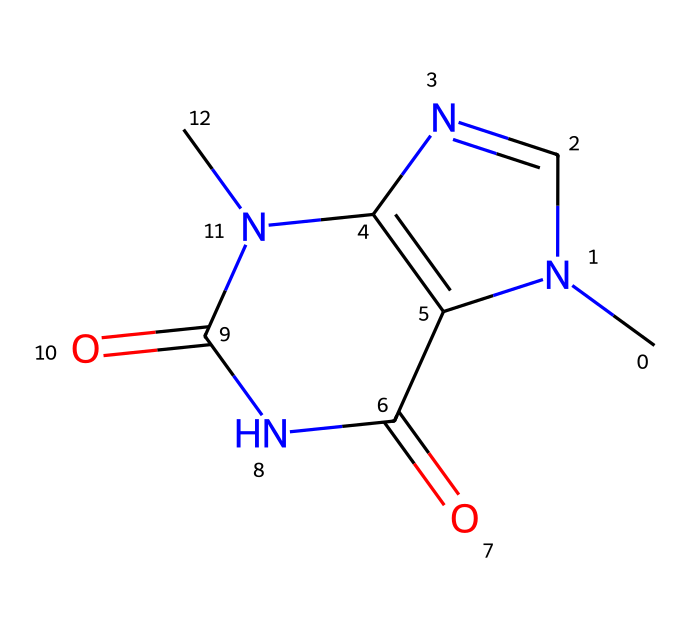what is the chemical name of this compound? The SMILES indicates the compound has a specific arrangement of atoms and functional groups typical of theobromine, which is a methylxanthine alkaloid found in chocolate.
Answer: theobromine how many nitrogen atoms are present in the structure? Analyzing the SMILES representation, there are four nitrogen atoms in the structure. This can be counted directly from the sequence of the structure where nitrogen is represented by "N."
Answer: four what is the total number of carbon atoms in the molecule? By breaking down the SMILES string, we can identify that there are seven carbon atoms present in the structure of theobromine.
Answer: seven do pigments in chocolate impact the flavor of this compound? The theobromine itself is responsible for distinct flavors, but other compounds, including pigments, also contribute to the overall taste profile. The nitrogen and carbon atoms provide the basic structure for theobromine.
Answer: yes which functional groups are present in this molecule? The presence of two carbonyl groups (C=O) and multiple nitrogen atoms characterizes the functional groups in theobromine, influencing its biochemical properties.
Answer: carbonyl and amine is this compound classified as a stimulant? Theobromine is well-known for its stimulating effects, similar to caffeine but milder, due to its structural similarity and interaction with adenosine receptors.
Answer: yes 